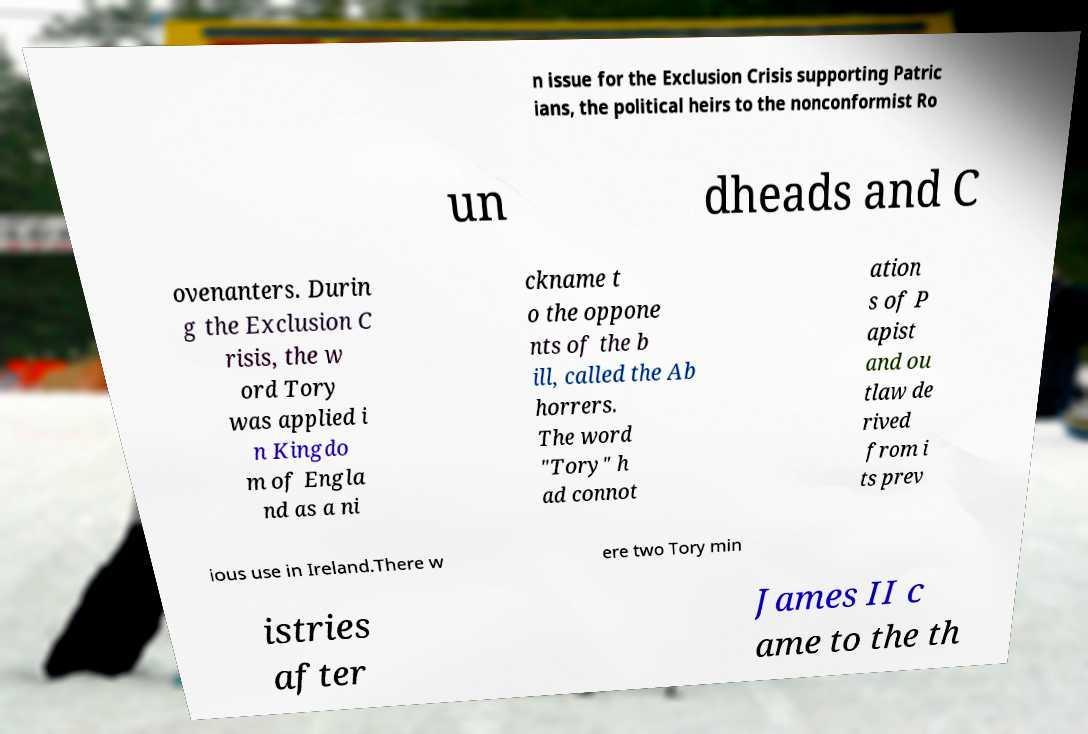There's text embedded in this image that I need extracted. Can you transcribe it verbatim? n issue for the Exclusion Crisis supporting Patric ians, the political heirs to the nonconformist Ro un dheads and C ovenanters. Durin g the Exclusion C risis, the w ord Tory was applied i n Kingdo m of Engla nd as a ni ckname t o the oppone nts of the b ill, called the Ab horrers. The word "Tory" h ad connot ation s of P apist and ou tlaw de rived from i ts prev ious use in Ireland.There w ere two Tory min istries after James II c ame to the th 